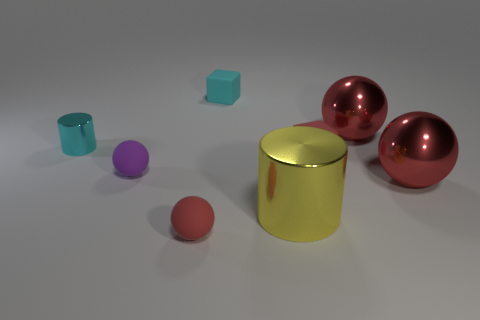What shape is the big yellow object?
Ensure brevity in your answer.  Cylinder. What shape is the red metal thing that is in front of the cylinder behind the big cylinder?
Give a very brief answer. Sphere. There is a tiny cube that is the same color as the tiny metallic cylinder; what material is it?
Provide a succinct answer. Rubber. Are there an equal number of large purple metallic blocks and small matte blocks?
Your response must be concise. No. The other cylinder that is the same material as the cyan cylinder is what color?
Offer a terse response. Yellow. Are there any other things that have the same size as the cyan matte object?
Your answer should be very brief. Yes. Does the small ball behind the yellow metallic thing have the same color as the small ball on the right side of the small purple ball?
Provide a short and direct response. No. Are there more small cyan cylinders left of the tiny shiny cylinder than tiny cyan metallic objects that are in front of the tiny purple sphere?
Keep it short and to the point. No. The other thing that is the same shape as the yellow object is what color?
Ensure brevity in your answer.  Cyan. Is there any other thing that is the same shape as the cyan rubber thing?
Make the answer very short. Yes. 